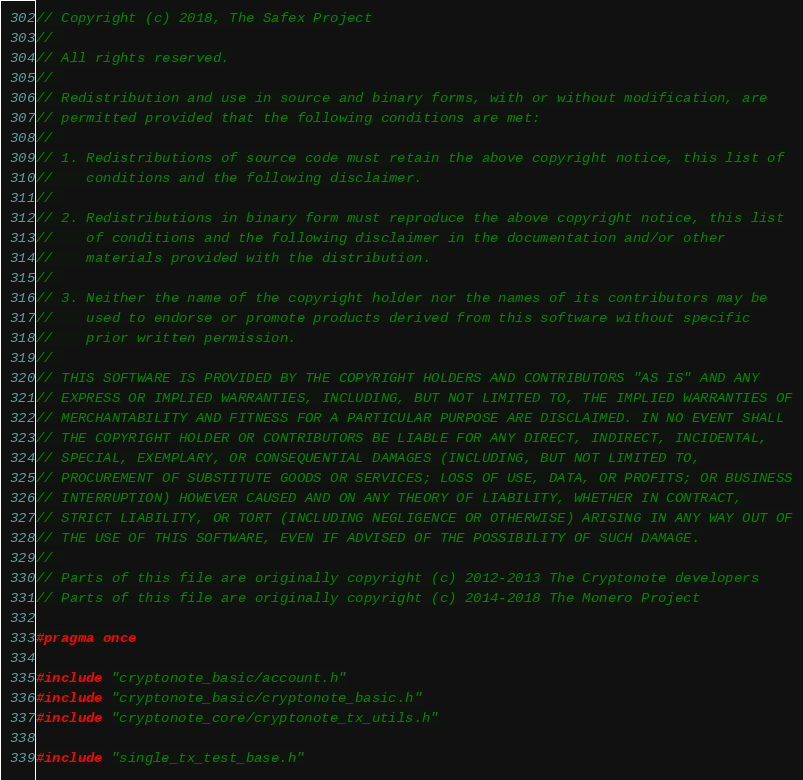Convert code to text. <code><loc_0><loc_0><loc_500><loc_500><_C_>// Copyright (c) 2018, The Safex Project
// 
// All rights reserved.
// 
// Redistribution and use in source and binary forms, with or without modification, are
// permitted provided that the following conditions are met:
// 
// 1. Redistributions of source code must retain the above copyright notice, this list of
//    conditions and the following disclaimer.
// 
// 2. Redistributions in binary form must reproduce the above copyright notice, this list
//    of conditions and the following disclaimer in the documentation and/or other
//    materials provided with the distribution.
// 
// 3. Neither the name of the copyright holder nor the names of its contributors may be
//    used to endorse or promote products derived from this software without specific
//    prior written permission.
// 
// THIS SOFTWARE IS PROVIDED BY THE COPYRIGHT HOLDERS AND CONTRIBUTORS "AS IS" AND ANY
// EXPRESS OR IMPLIED WARRANTIES, INCLUDING, BUT NOT LIMITED TO, THE IMPLIED WARRANTIES OF
// MERCHANTABILITY AND FITNESS FOR A PARTICULAR PURPOSE ARE DISCLAIMED. IN NO EVENT SHALL
// THE COPYRIGHT HOLDER OR CONTRIBUTORS BE LIABLE FOR ANY DIRECT, INDIRECT, INCIDENTAL,
// SPECIAL, EXEMPLARY, OR CONSEQUENTIAL DAMAGES (INCLUDING, BUT NOT LIMITED TO,
// PROCUREMENT OF SUBSTITUTE GOODS OR SERVICES; LOSS OF USE, DATA, OR PROFITS; OR BUSINESS
// INTERRUPTION) HOWEVER CAUSED AND ON ANY THEORY OF LIABILITY, WHETHER IN CONTRACT,
// STRICT LIABILITY, OR TORT (INCLUDING NEGLIGENCE OR OTHERWISE) ARISING IN ANY WAY OUT OF
// THE USE OF THIS SOFTWARE, EVEN IF ADVISED OF THE POSSIBILITY OF SUCH DAMAGE.
// 
// Parts of this file are originally copyright (c) 2012-2013 The Cryptonote developers
// Parts of this file are originally copyright (c) 2014-2018 The Monero Project

#pragma once

#include "cryptonote_basic/account.h"
#include "cryptonote_basic/cryptonote_basic.h"
#include "cryptonote_core/cryptonote_tx_utils.h"

#include "single_tx_test_base.h"
</code> 